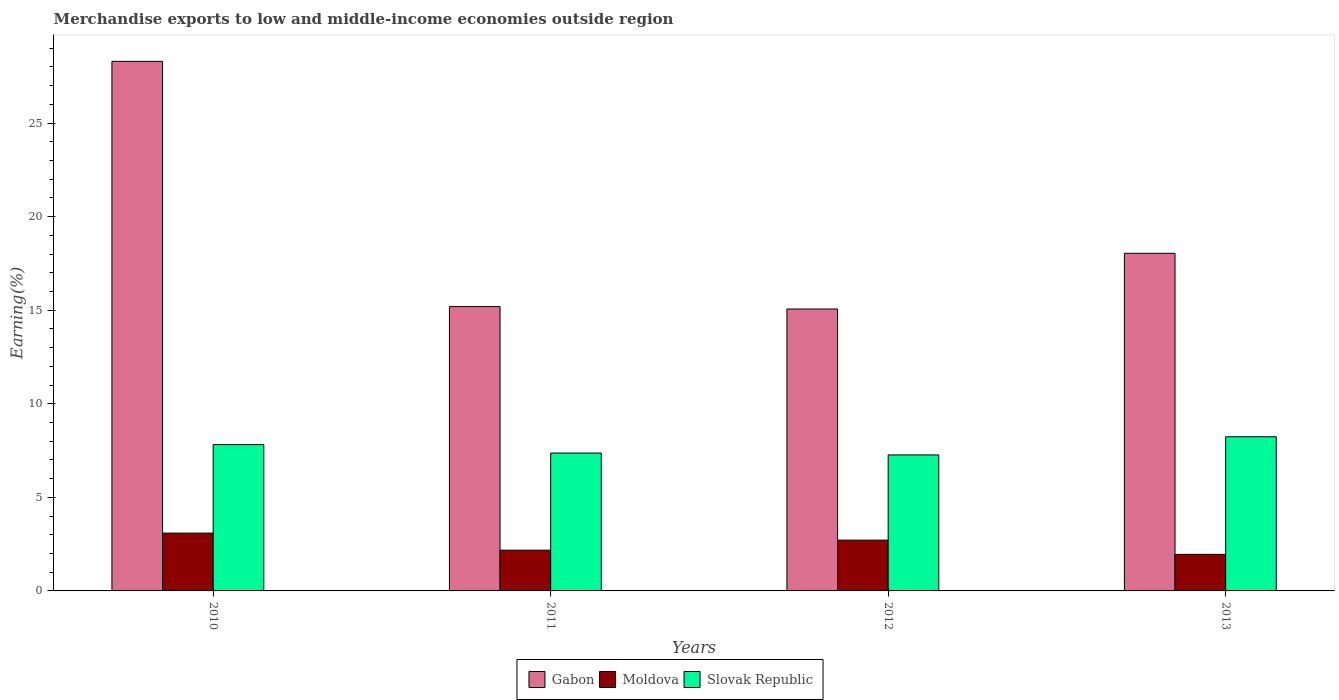Are the number of bars per tick equal to the number of legend labels?
Make the answer very short. Yes. Are the number of bars on each tick of the X-axis equal?
Provide a succinct answer. Yes. How many bars are there on the 1st tick from the left?
Offer a terse response. 3. How many bars are there on the 2nd tick from the right?
Keep it short and to the point. 3. What is the label of the 3rd group of bars from the left?
Your answer should be very brief. 2012. What is the percentage of amount earned from merchandise exports in Gabon in 2013?
Offer a terse response. 18.04. Across all years, what is the maximum percentage of amount earned from merchandise exports in Moldova?
Offer a terse response. 3.09. Across all years, what is the minimum percentage of amount earned from merchandise exports in Gabon?
Ensure brevity in your answer.  15.06. In which year was the percentage of amount earned from merchandise exports in Gabon maximum?
Provide a short and direct response. 2010. What is the total percentage of amount earned from merchandise exports in Slovak Republic in the graph?
Offer a very short reply. 30.69. What is the difference between the percentage of amount earned from merchandise exports in Slovak Republic in 2010 and that in 2012?
Provide a succinct answer. 0.55. What is the difference between the percentage of amount earned from merchandise exports in Slovak Republic in 2010 and the percentage of amount earned from merchandise exports in Gabon in 2012?
Keep it short and to the point. -7.24. What is the average percentage of amount earned from merchandise exports in Slovak Republic per year?
Offer a very short reply. 7.67. In the year 2010, what is the difference between the percentage of amount earned from merchandise exports in Slovak Republic and percentage of amount earned from merchandise exports in Moldova?
Provide a short and direct response. 4.73. What is the ratio of the percentage of amount earned from merchandise exports in Gabon in 2011 to that in 2012?
Give a very brief answer. 1.01. Is the percentage of amount earned from merchandise exports in Moldova in 2010 less than that in 2013?
Your answer should be compact. No. Is the difference between the percentage of amount earned from merchandise exports in Slovak Republic in 2012 and 2013 greater than the difference between the percentage of amount earned from merchandise exports in Moldova in 2012 and 2013?
Keep it short and to the point. No. What is the difference between the highest and the second highest percentage of amount earned from merchandise exports in Gabon?
Offer a very short reply. 10.26. What is the difference between the highest and the lowest percentage of amount earned from merchandise exports in Slovak Republic?
Your answer should be very brief. 0.97. Is the sum of the percentage of amount earned from merchandise exports in Slovak Republic in 2012 and 2013 greater than the maximum percentage of amount earned from merchandise exports in Moldova across all years?
Offer a very short reply. Yes. What does the 1st bar from the left in 2012 represents?
Make the answer very short. Gabon. What does the 1st bar from the right in 2012 represents?
Your answer should be very brief. Slovak Republic. Is it the case that in every year, the sum of the percentage of amount earned from merchandise exports in Gabon and percentage of amount earned from merchandise exports in Moldova is greater than the percentage of amount earned from merchandise exports in Slovak Republic?
Offer a very short reply. Yes. Are the values on the major ticks of Y-axis written in scientific E-notation?
Make the answer very short. No. Does the graph contain grids?
Your response must be concise. No. Where does the legend appear in the graph?
Offer a very short reply. Bottom center. How many legend labels are there?
Provide a short and direct response. 3. How are the legend labels stacked?
Offer a very short reply. Horizontal. What is the title of the graph?
Offer a very short reply. Merchandise exports to low and middle-income economies outside region. Does "Middle East & North Africa (developing only)" appear as one of the legend labels in the graph?
Your response must be concise. No. What is the label or title of the X-axis?
Make the answer very short. Years. What is the label or title of the Y-axis?
Provide a short and direct response. Earning(%). What is the Earning(%) in Gabon in 2010?
Ensure brevity in your answer.  28.3. What is the Earning(%) of Moldova in 2010?
Ensure brevity in your answer.  3.09. What is the Earning(%) of Slovak Republic in 2010?
Make the answer very short. 7.82. What is the Earning(%) in Gabon in 2011?
Keep it short and to the point. 15.19. What is the Earning(%) in Moldova in 2011?
Your answer should be very brief. 2.18. What is the Earning(%) of Slovak Republic in 2011?
Make the answer very short. 7.37. What is the Earning(%) of Gabon in 2012?
Your answer should be very brief. 15.06. What is the Earning(%) in Moldova in 2012?
Ensure brevity in your answer.  2.71. What is the Earning(%) in Slovak Republic in 2012?
Make the answer very short. 7.27. What is the Earning(%) in Gabon in 2013?
Offer a terse response. 18.04. What is the Earning(%) in Moldova in 2013?
Your response must be concise. 1.95. What is the Earning(%) of Slovak Republic in 2013?
Ensure brevity in your answer.  8.24. Across all years, what is the maximum Earning(%) of Gabon?
Give a very brief answer. 28.3. Across all years, what is the maximum Earning(%) of Moldova?
Make the answer very short. 3.09. Across all years, what is the maximum Earning(%) in Slovak Republic?
Your answer should be very brief. 8.24. Across all years, what is the minimum Earning(%) in Gabon?
Offer a very short reply. 15.06. Across all years, what is the minimum Earning(%) in Moldova?
Your answer should be very brief. 1.95. Across all years, what is the minimum Earning(%) of Slovak Republic?
Give a very brief answer. 7.27. What is the total Earning(%) of Gabon in the graph?
Ensure brevity in your answer.  76.59. What is the total Earning(%) in Moldova in the graph?
Offer a very short reply. 9.93. What is the total Earning(%) of Slovak Republic in the graph?
Offer a terse response. 30.69. What is the difference between the Earning(%) of Gabon in 2010 and that in 2011?
Provide a succinct answer. 13.1. What is the difference between the Earning(%) in Moldova in 2010 and that in 2011?
Provide a short and direct response. 0.91. What is the difference between the Earning(%) in Slovak Republic in 2010 and that in 2011?
Ensure brevity in your answer.  0.45. What is the difference between the Earning(%) of Gabon in 2010 and that in 2012?
Ensure brevity in your answer.  13.23. What is the difference between the Earning(%) of Moldova in 2010 and that in 2012?
Ensure brevity in your answer.  0.38. What is the difference between the Earning(%) of Slovak Republic in 2010 and that in 2012?
Your answer should be compact. 0.55. What is the difference between the Earning(%) of Gabon in 2010 and that in 2013?
Provide a succinct answer. 10.26. What is the difference between the Earning(%) of Moldova in 2010 and that in 2013?
Provide a succinct answer. 1.14. What is the difference between the Earning(%) of Slovak Republic in 2010 and that in 2013?
Your response must be concise. -0.42. What is the difference between the Earning(%) in Gabon in 2011 and that in 2012?
Your answer should be very brief. 0.13. What is the difference between the Earning(%) of Moldova in 2011 and that in 2012?
Provide a short and direct response. -0.54. What is the difference between the Earning(%) of Slovak Republic in 2011 and that in 2012?
Provide a succinct answer. 0.1. What is the difference between the Earning(%) of Gabon in 2011 and that in 2013?
Keep it short and to the point. -2.85. What is the difference between the Earning(%) in Moldova in 2011 and that in 2013?
Give a very brief answer. 0.22. What is the difference between the Earning(%) of Slovak Republic in 2011 and that in 2013?
Offer a very short reply. -0.87. What is the difference between the Earning(%) of Gabon in 2012 and that in 2013?
Keep it short and to the point. -2.98. What is the difference between the Earning(%) in Moldova in 2012 and that in 2013?
Your answer should be very brief. 0.76. What is the difference between the Earning(%) of Slovak Republic in 2012 and that in 2013?
Provide a short and direct response. -0.97. What is the difference between the Earning(%) of Gabon in 2010 and the Earning(%) of Moldova in 2011?
Ensure brevity in your answer.  26.12. What is the difference between the Earning(%) in Gabon in 2010 and the Earning(%) in Slovak Republic in 2011?
Keep it short and to the point. 20.93. What is the difference between the Earning(%) of Moldova in 2010 and the Earning(%) of Slovak Republic in 2011?
Keep it short and to the point. -4.28. What is the difference between the Earning(%) in Gabon in 2010 and the Earning(%) in Moldova in 2012?
Make the answer very short. 25.58. What is the difference between the Earning(%) in Gabon in 2010 and the Earning(%) in Slovak Republic in 2012?
Make the answer very short. 21.03. What is the difference between the Earning(%) of Moldova in 2010 and the Earning(%) of Slovak Republic in 2012?
Make the answer very short. -4.18. What is the difference between the Earning(%) of Gabon in 2010 and the Earning(%) of Moldova in 2013?
Give a very brief answer. 26.34. What is the difference between the Earning(%) in Gabon in 2010 and the Earning(%) in Slovak Republic in 2013?
Your answer should be very brief. 20.06. What is the difference between the Earning(%) in Moldova in 2010 and the Earning(%) in Slovak Republic in 2013?
Your answer should be very brief. -5.15. What is the difference between the Earning(%) in Gabon in 2011 and the Earning(%) in Moldova in 2012?
Give a very brief answer. 12.48. What is the difference between the Earning(%) of Gabon in 2011 and the Earning(%) of Slovak Republic in 2012?
Your answer should be compact. 7.93. What is the difference between the Earning(%) of Moldova in 2011 and the Earning(%) of Slovak Republic in 2012?
Provide a short and direct response. -5.09. What is the difference between the Earning(%) in Gabon in 2011 and the Earning(%) in Moldova in 2013?
Offer a terse response. 13.24. What is the difference between the Earning(%) in Gabon in 2011 and the Earning(%) in Slovak Republic in 2013?
Your answer should be very brief. 6.96. What is the difference between the Earning(%) in Moldova in 2011 and the Earning(%) in Slovak Republic in 2013?
Your answer should be very brief. -6.06. What is the difference between the Earning(%) of Gabon in 2012 and the Earning(%) of Moldova in 2013?
Give a very brief answer. 13.11. What is the difference between the Earning(%) in Gabon in 2012 and the Earning(%) in Slovak Republic in 2013?
Make the answer very short. 6.83. What is the difference between the Earning(%) in Moldova in 2012 and the Earning(%) in Slovak Republic in 2013?
Ensure brevity in your answer.  -5.52. What is the average Earning(%) of Gabon per year?
Ensure brevity in your answer.  19.15. What is the average Earning(%) in Moldova per year?
Your answer should be compact. 2.48. What is the average Earning(%) in Slovak Republic per year?
Ensure brevity in your answer.  7.67. In the year 2010, what is the difference between the Earning(%) in Gabon and Earning(%) in Moldova?
Provide a short and direct response. 25.21. In the year 2010, what is the difference between the Earning(%) in Gabon and Earning(%) in Slovak Republic?
Provide a succinct answer. 20.48. In the year 2010, what is the difference between the Earning(%) in Moldova and Earning(%) in Slovak Republic?
Your response must be concise. -4.73. In the year 2011, what is the difference between the Earning(%) of Gabon and Earning(%) of Moldova?
Keep it short and to the point. 13.02. In the year 2011, what is the difference between the Earning(%) of Gabon and Earning(%) of Slovak Republic?
Give a very brief answer. 7.83. In the year 2011, what is the difference between the Earning(%) in Moldova and Earning(%) in Slovak Republic?
Keep it short and to the point. -5.19. In the year 2012, what is the difference between the Earning(%) in Gabon and Earning(%) in Moldova?
Provide a succinct answer. 12.35. In the year 2012, what is the difference between the Earning(%) of Gabon and Earning(%) of Slovak Republic?
Make the answer very short. 7.8. In the year 2012, what is the difference between the Earning(%) of Moldova and Earning(%) of Slovak Republic?
Ensure brevity in your answer.  -4.55. In the year 2013, what is the difference between the Earning(%) in Gabon and Earning(%) in Moldova?
Your answer should be very brief. 16.09. In the year 2013, what is the difference between the Earning(%) of Gabon and Earning(%) of Slovak Republic?
Your response must be concise. 9.8. In the year 2013, what is the difference between the Earning(%) of Moldova and Earning(%) of Slovak Republic?
Provide a succinct answer. -6.28. What is the ratio of the Earning(%) in Gabon in 2010 to that in 2011?
Your answer should be very brief. 1.86. What is the ratio of the Earning(%) of Moldova in 2010 to that in 2011?
Give a very brief answer. 1.42. What is the ratio of the Earning(%) of Slovak Republic in 2010 to that in 2011?
Provide a succinct answer. 1.06. What is the ratio of the Earning(%) in Gabon in 2010 to that in 2012?
Ensure brevity in your answer.  1.88. What is the ratio of the Earning(%) of Moldova in 2010 to that in 2012?
Your answer should be compact. 1.14. What is the ratio of the Earning(%) in Slovak Republic in 2010 to that in 2012?
Your answer should be compact. 1.08. What is the ratio of the Earning(%) of Gabon in 2010 to that in 2013?
Offer a very short reply. 1.57. What is the ratio of the Earning(%) of Moldova in 2010 to that in 2013?
Make the answer very short. 1.58. What is the ratio of the Earning(%) in Slovak Republic in 2010 to that in 2013?
Your response must be concise. 0.95. What is the ratio of the Earning(%) in Gabon in 2011 to that in 2012?
Provide a short and direct response. 1.01. What is the ratio of the Earning(%) of Moldova in 2011 to that in 2012?
Offer a very short reply. 0.8. What is the ratio of the Earning(%) of Slovak Republic in 2011 to that in 2012?
Your response must be concise. 1.01. What is the ratio of the Earning(%) in Gabon in 2011 to that in 2013?
Give a very brief answer. 0.84. What is the ratio of the Earning(%) of Moldova in 2011 to that in 2013?
Ensure brevity in your answer.  1.12. What is the ratio of the Earning(%) of Slovak Republic in 2011 to that in 2013?
Your answer should be compact. 0.89. What is the ratio of the Earning(%) of Gabon in 2012 to that in 2013?
Your answer should be very brief. 0.83. What is the ratio of the Earning(%) in Moldova in 2012 to that in 2013?
Ensure brevity in your answer.  1.39. What is the ratio of the Earning(%) of Slovak Republic in 2012 to that in 2013?
Offer a terse response. 0.88. What is the difference between the highest and the second highest Earning(%) in Gabon?
Keep it short and to the point. 10.26. What is the difference between the highest and the second highest Earning(%) of Slovak Republic?
Offer a terse response. 0.42. What is the difference between the highest and the lowest Earning(%) in Gabon?
Provide a short and direct response. 13.23. What is the difference between the highest and the lowest Earning(%) of Moldova?
Ensure brevity in your answer.  1.14. What is the difference between the highest and the lowest Earning(%) of Slovak Republic?
Your answer should be compact. 0.97. 